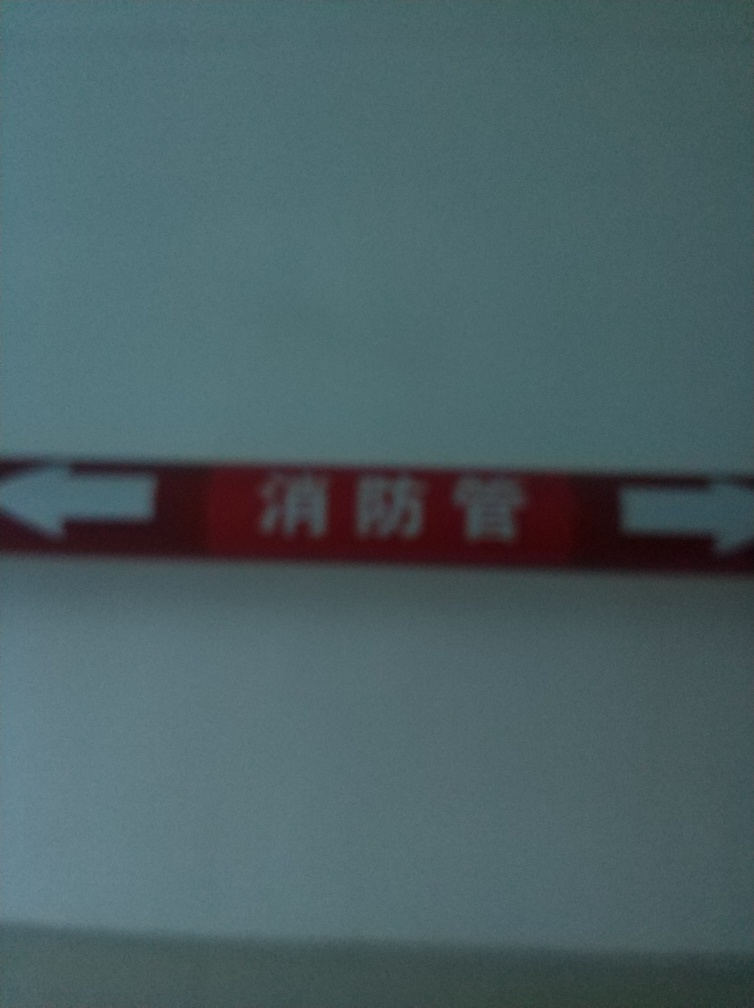Can you tell what the sign might be indicating? Although the specific details are obscured by the low resolution, the sign appears to have directional arrows which might suggest it is guiding towards certain locations or areas. The color red often denotes caution or prohibition, potentially indicating a warning or restricted access site if contextually relevant. Is there any legible text on the sign that can be made out? Due to the blur, exact text identification is challenging; however, it seems to contain characters from a non-Latin script, potentially East Asian. Unfortunately, without higher clarity, the precise message remains undeciphered. 